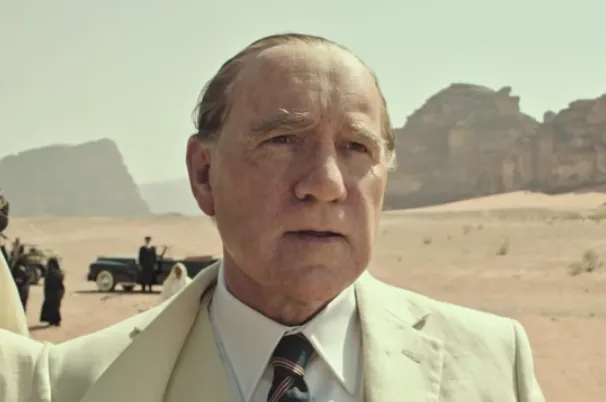What does the background setting suggest about the scene depicted in the image? The vast, barren desert depicted in the background sets a stark, almost bleak stage, suggesting themes of emptiness and isolation despite wealth. It indicates that the character, despite his financial capabilities, faces situations or decisions that are desolate or challenging, mirroring the harsh surroundings. 